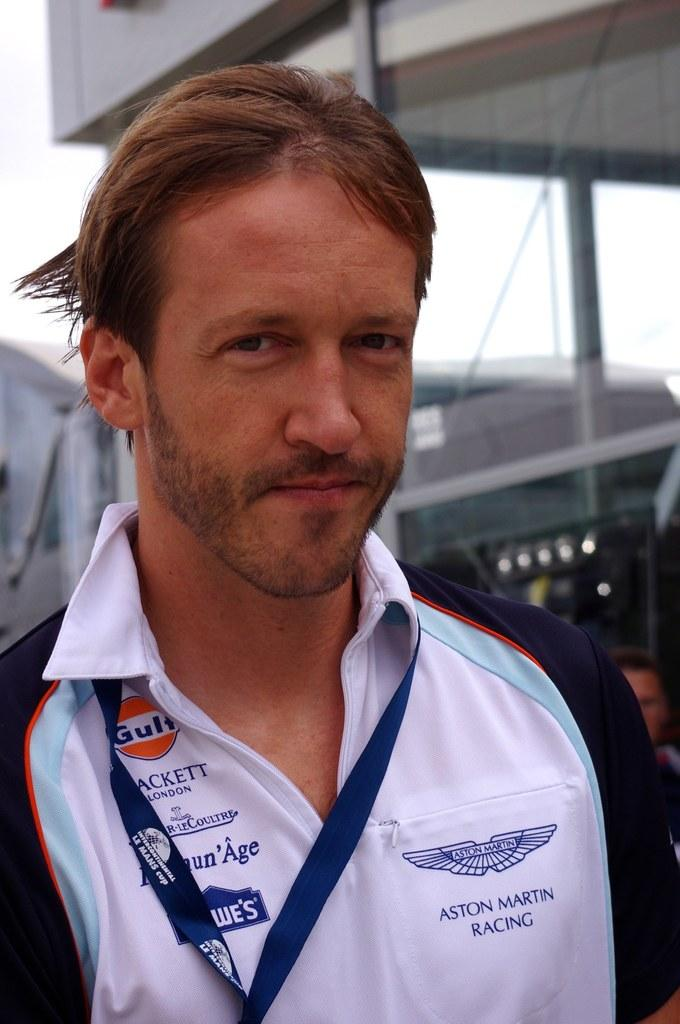Provide a one-sentence caption for the provided image. A man with a white shirt that says Aston Martin Racing on the left side and Lowes on the left. 